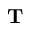Convert formula to latex. <formula><loc_0><loc_0><loc_500><loc_500>T</formula> 